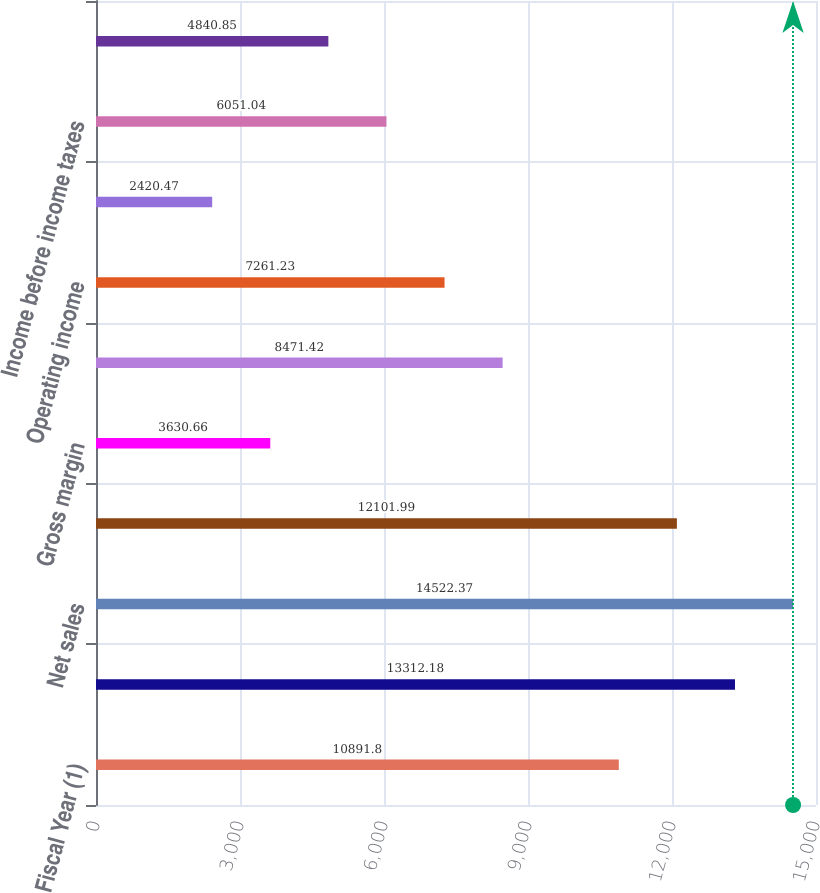<chart> <loc_0><loc_0><loc_500><loc_500><bar_chart><fcel>Fiscal Year (1)<fcel>New orders<fcel>Net sales<fcel>Gross profit<fcel>Gross margin<fcel>Research development and<fcel>Operating income<fcel>Operating margin<fcel>Income before income taxes<fcel>Net income<nl><fcel>10891.8<fcel>13312.2<fcel>14522.4<fcel>12102<fcel>3630.66<fcel>8471.42<fcel>7261.23<fcel>2420.47<fcel>6051.04<fcel>4840.85<nl></chart> 